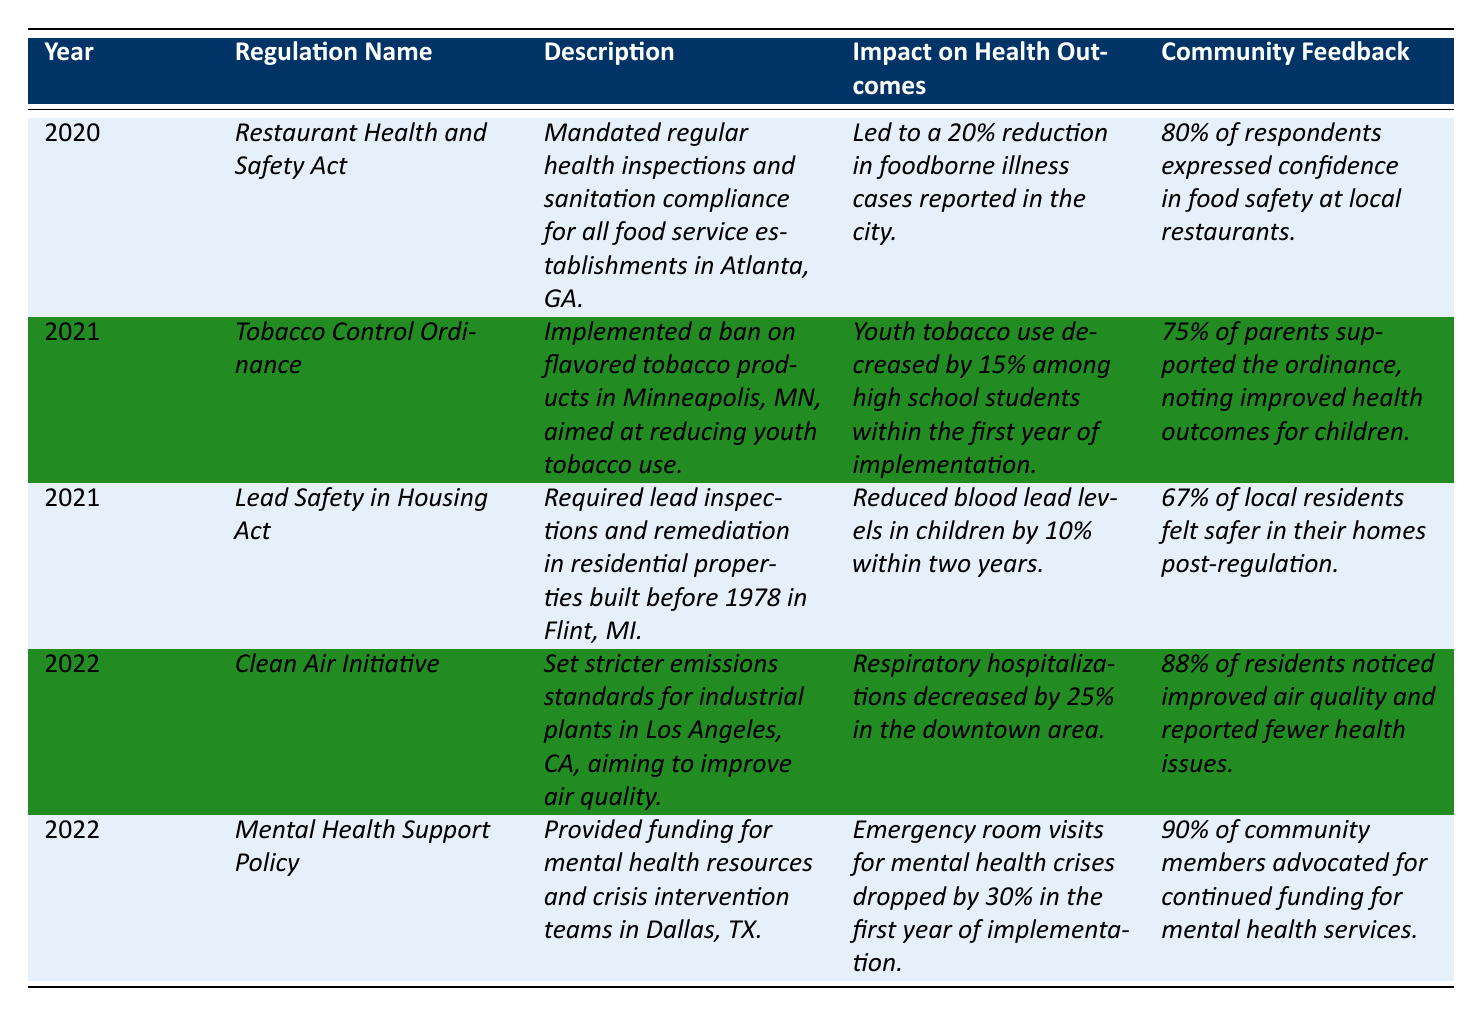What regulation led to a 20% reduction in foodborne illness cases? The "*Restaurant Health and Safety Act*" is the regulation mentioned in the table that resulted in a 20% reduction in foodborne illness cases in Atlanta, GA.
Answer: *Restaurant Health and Safety Act* How many respondents expressed confidence in food safety at local restaurants after the implementation of the *Restaurant Health and Safety Act*? According to the table, 80% of respondents expressed confidence in food safety at local restaurants following the *Restaurant Health and Safety Act*.
Answer: 80% Which regulation implemented a ban on flavored tobacco products? The regulation that implemented a ban on flavored tobacco products is the "*Tobacco Control Ordinance*" as noted in the table under the year 2021.
Answer: *Tobacco Control Ordinance* What was the impact on community feedback regarding the *Clean Air Initiative*? The community feedback tabled indicates that 88% of residents noticed improved air quality and reported fewer health issues after the implementation of the *Clean Air Initiative*.
Answer: 88% How much did youth tobacco use decrease among high school students in the first year of the *Tobacco Control Ordinance*? The table states that youth tobacco use decreased by 15% among high school students within the first year after the *Tobacco Control Ordinance* was implemented.
Answer: 15% What percentage of local residents felt safer in their homes after the *Lead Safety in Housing Act*? According to the table, 67% of local residents felt safer in their homes after the *Lead Safety in Housing Act* was put into effect.
Answer: 67% What was the reduction in blood lead levels in children after the *Lead Safety in Housing Act*? The table indicates a 10% reduction in blood lead levels in children within two years after the *Lead Safety in Housing Act* was enacted.
Answer: 10% Which regulation had the highest percentage of community members advocating for continued funding? The *Mental Health Support Policy* had the highest percentage, with 90% of community members advocating for continued funding for mental health services, based on the table data.
Answer: *Mental Health Support Policy* If the *Mental Health Support Policy* reduced emergency room visits by 30%, what was the implication for mental health crises in the community? The implication is significant; a 30% drop in emergency room visits for mental health crises suggests that the policy effectively addressed mental health issues in the community, according to the table's impact on health outcomes.
Answer: Significant improvement What was the overall trend of health outcomes following the regulations from 2020 to 2022 based on the table? The overall trend indicated a reduction in health issues such as foodborne illnesses, youth tobacco use, blood lead levels, respiratory hospitalizations, and mental health crises following the implementation of these regulations.
Answer: Positive trend 